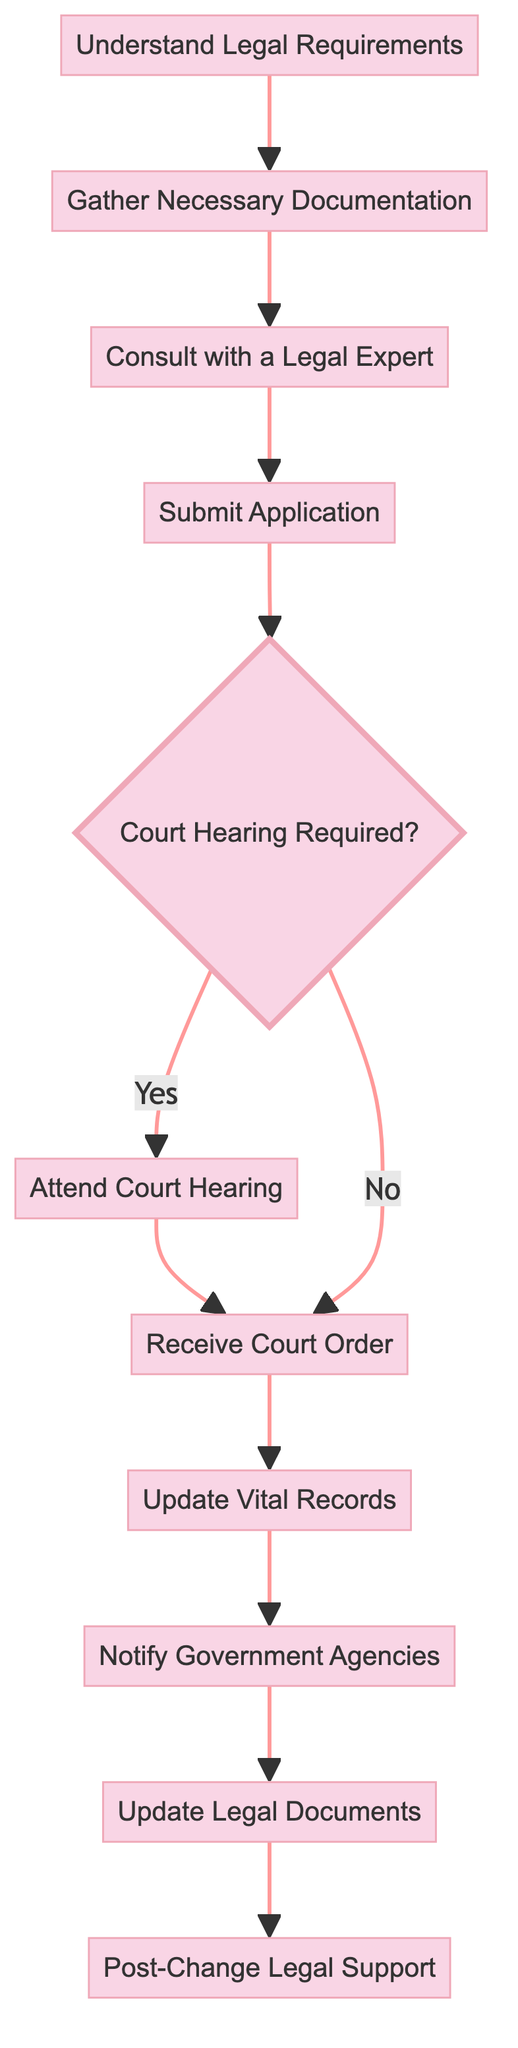What is the first step in the process? The first step in the flow chart is labeled "Understand Legal Requirements." It is the topmost node and serves as the starting point of the process for changing gender markers.
Answer: Understand Legal Requirements How many total steps are there in the process? Counting all the nodes in the flow chart, there are ten process steps displayed from "Understand Legal Requirements" to "Post-Change Legal Support." Each process node represents a necessary action to navigate the legal process.
Answer: Ten What is the decision point in the diagram? The diagram features a decision point labeled "Court Hearing Required?" that indicates whether or not a court hearing is necessary based on the situation of the individual requesting the gender marker change.
Answer: Court Hearing Required? What documents are needed before consulting a legal expert? Before consulting a legal expert, the necessary documentation must be gathered, including the birth certificate, court order, medical certification, and identification proof. This step is crucial for having a comprehensive discussion with the lawyer.
Answer: Gather Necessary Documentation What happens after receiving the court order? After obtaining the court order, the next step is to "Update Vital Records." This means the individual will use the court order to change their birth certificate and other important records to reflect their new gender marker, ensuring all legal documents are consistent.
Answer: Update Vital Records Are there any steps following the notification of government agencies? Yes, after notifying government agencies, the process continues to "Update Legal Documents." This step involves revising essential legal documents like passports, driver's licenses, and insurance records to incorporate the updated gender marker.
Answer: Update Legal Documents How does one seek ongoing support after changing their gender marker? Following the entire process, individuals should seek "Post-Change Legal Support" to help address any potential complications or discrimination issues they may face after the legal change has been finalized. This step ensures continuous advocacy and support.
Answer: Post-Change Legal Support What is the last action in the flow chart? The final action in the flow chart is "Post-Change Legal Support," which emphasizes the importance of ongoing assistance after the completion of the gender marker change process to mitigate any challenges or discrimination that may arise.
Answer: Post-Change Legal Support What comes immediately after the 'Submit Application' step if a court hearing is not required? If a court hearing is not required after the 'Submit Application' step, the next action is to "Receive Court Order." This indicates that the process will proceed smoothly without needing court intervention.
Answer: Receive Court Order 